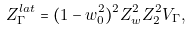Convert formula to latex. <formula><loc_0><loc_0><loc_500><loc_500>Z _ { \Gamma } ^ { l a t } = ( 1 - w _ { 0 } ^ { 2 } ) ^ { 2 } Z _ { w } ^ { 2 } Z _ { 2 } ^ { 2 } V _ { \Gamma } ,</formula> 